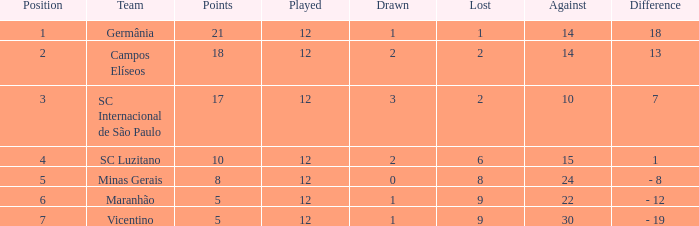What is the sum of drawn that has a played more than 12? 0.0. 